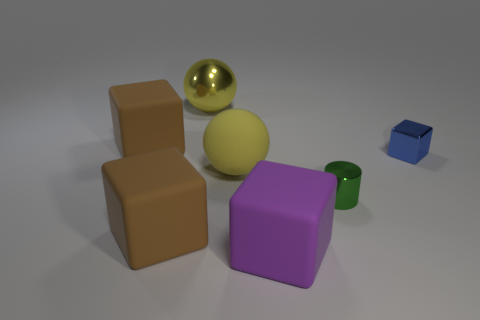The metallic cylinder has what color?
Give a very brief answer. Green. What number of things are cubes that are behind the large purple matte thing or blue metal cylinders?
Provide a short and direct response. 3. There is a brown matte thing that is in front of the yellow rubber thing; does it have the same size as the block right of the big purple object?
Provide a short and direct response. No. Is there any other thing that is made of the same material as the cylinder?
Keep it short and to the point. Yes. What number of objects are matte objects that are on the right side of the yellow shiny thing or blocks on the left side of the small green cylinder?
Your answer should be very brief. 4. Is the cylinder made of the same material as the big yellow thing on the right side of the yellow metallic object?
Provide a short and direct response. No. What shape is the object that is on the right side of the big yellow matte sphere and to the left of the green cylinder?
Offer a very short reply. Cube. How many other things are the same color as the shiny ball?
Offer a terse response. 1. The big metal object is what shape?
Your answer should be very brief. Sphere. What color is the sphere that is behind the big brown thing that is behind the green metallic thing?
Your response must be concise. Yellow. 